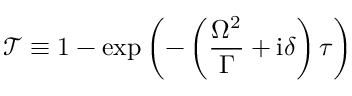<formula> <loc_0><loc_0><loc_500><loc_500>\mathcal { T } \equiv 1 - \exp \left ( - \left ( \frac { \Omega ^ { 2 } } { \Gamma } + i \delta \right ) \tau \right )</formula> 